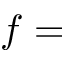<formula> <loc_0><loc_0><loc_500><loc_500>f =</formula> 